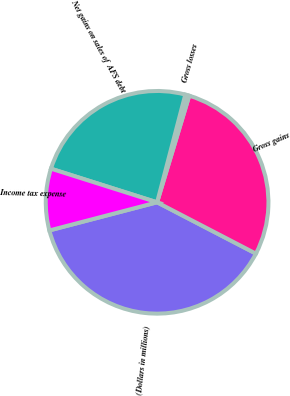Convert chart. <chart><loc_0><loc_0><loc_500><loc_500><pie_chart><fcel>(Dollars in millions)<fcel>Gross gains<fcel>Gross losses<fcel>Net gains on sales of AFS debt<fcel>Income tax expense<nl><fcel>38.31%<fcel>27.96%<fcel>0.59%<fcel>24.19%<fcel>8.95%<nl></chart> 